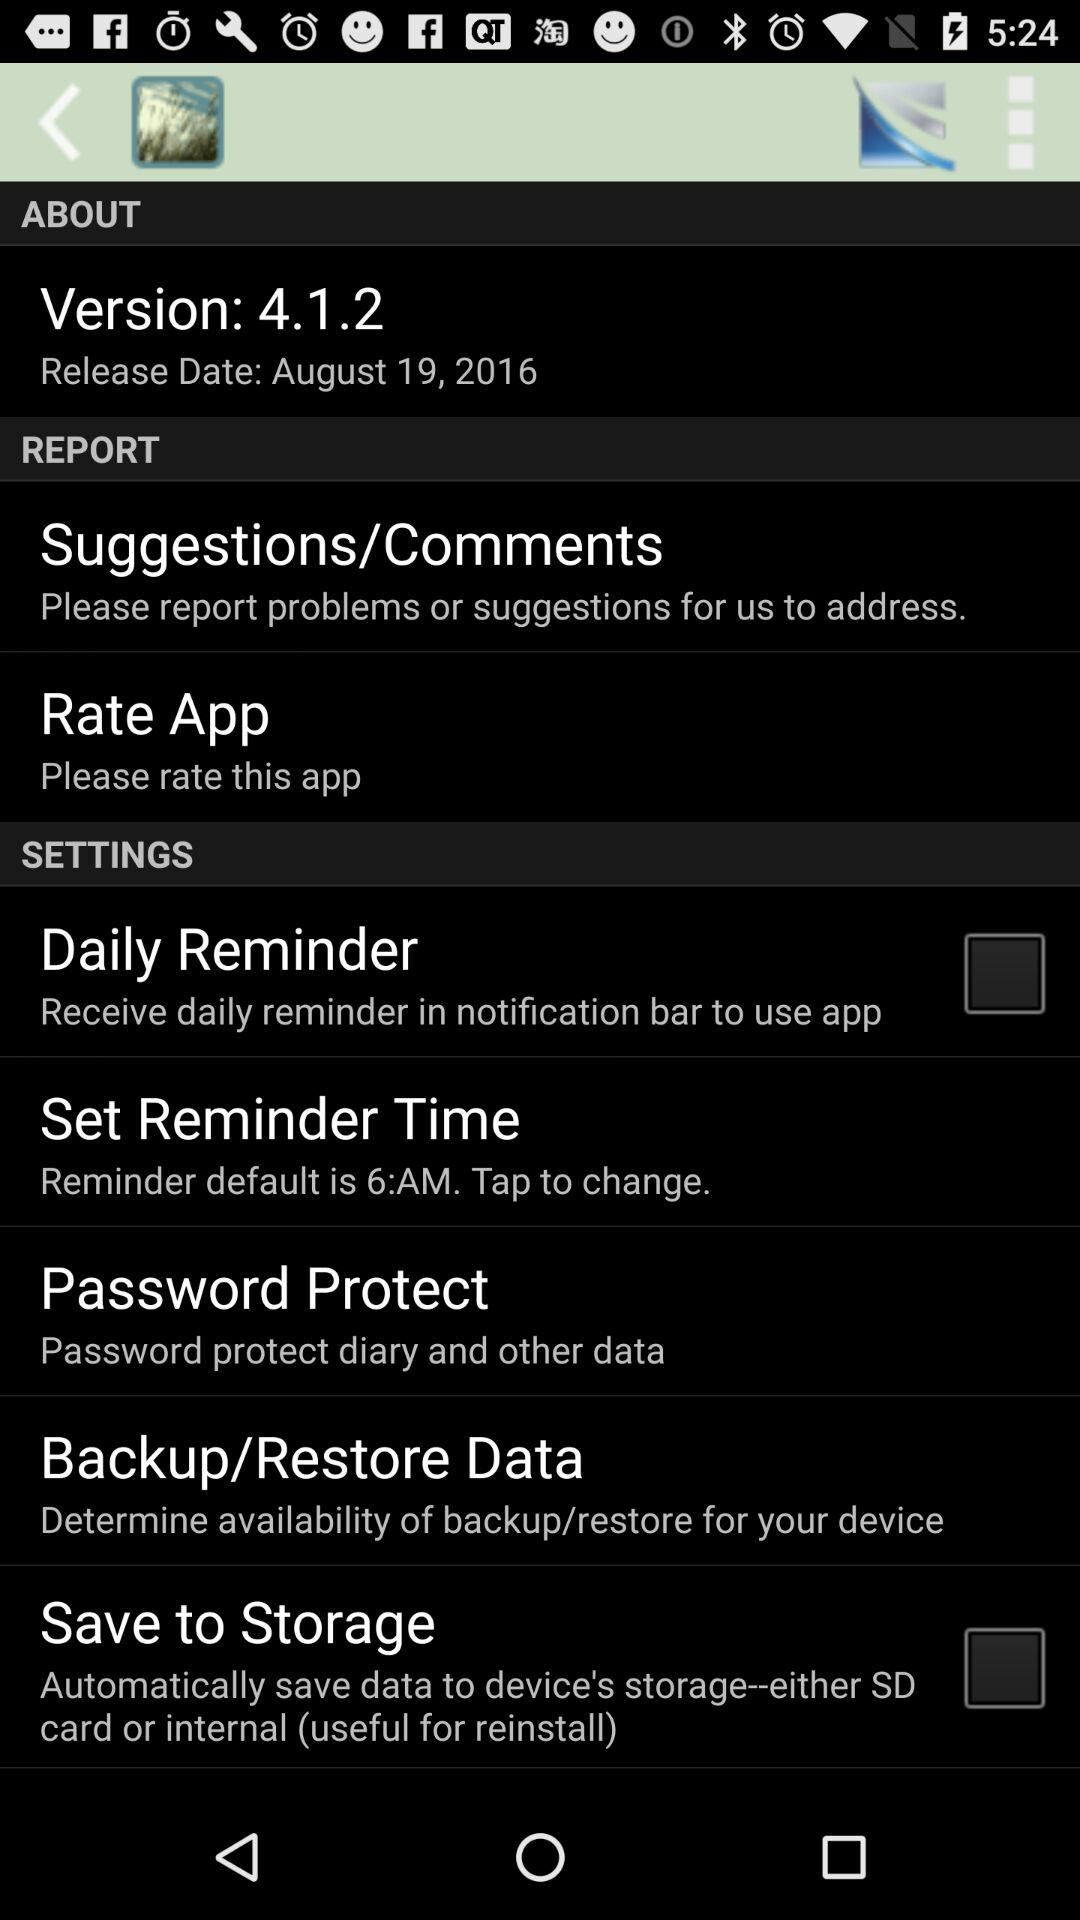What time is set for the reminder? The time set for the reminder is 6 a.m. 